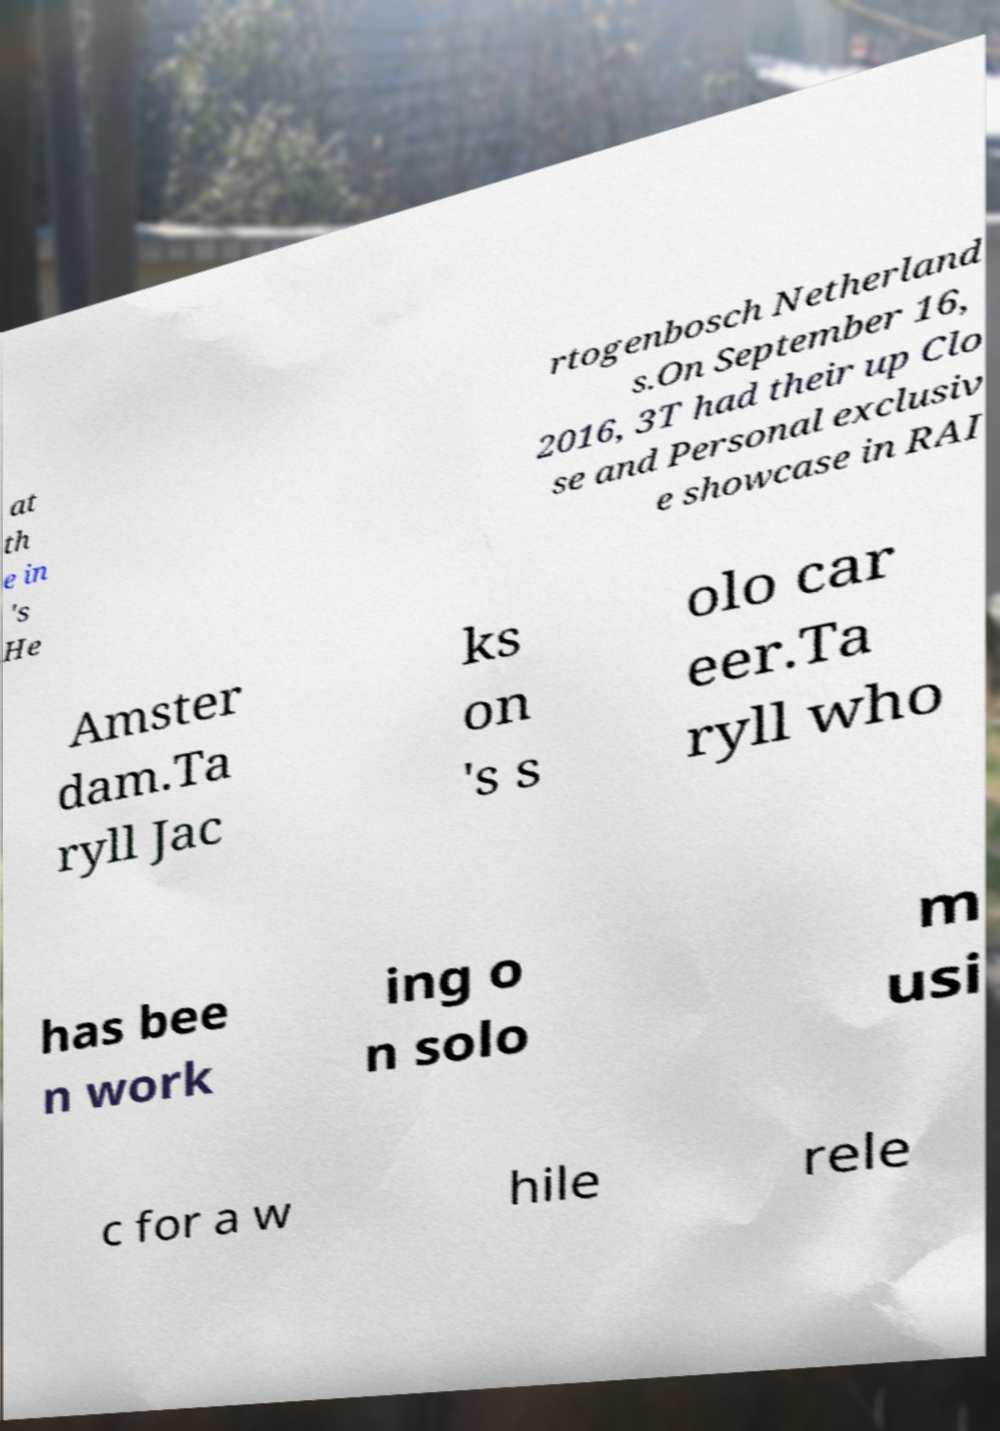Please read and relay the text visible in this image. What does it say? at th e in 's He rtogenbosch Netherland s.On September 16, 2016, 3T had their up Clo se and Personal exclusiv e showcase in RAI Amster dam.Ta ryll Jac ks on 's s olo car eer.Ta ryll who has bee n work ing o n solo m usi c for a w hile rele 